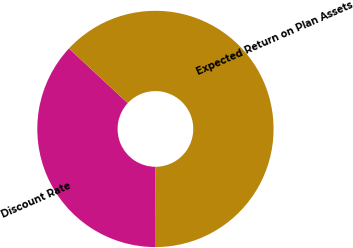<chart> <loc_0><loc_0><loc_500><loc_500><pie_chart><fcel>Discount Rate<fcel>Expected Return on Plan Assets<nl><fcel>36.97%<fcel>63.03%<nl></chart> 